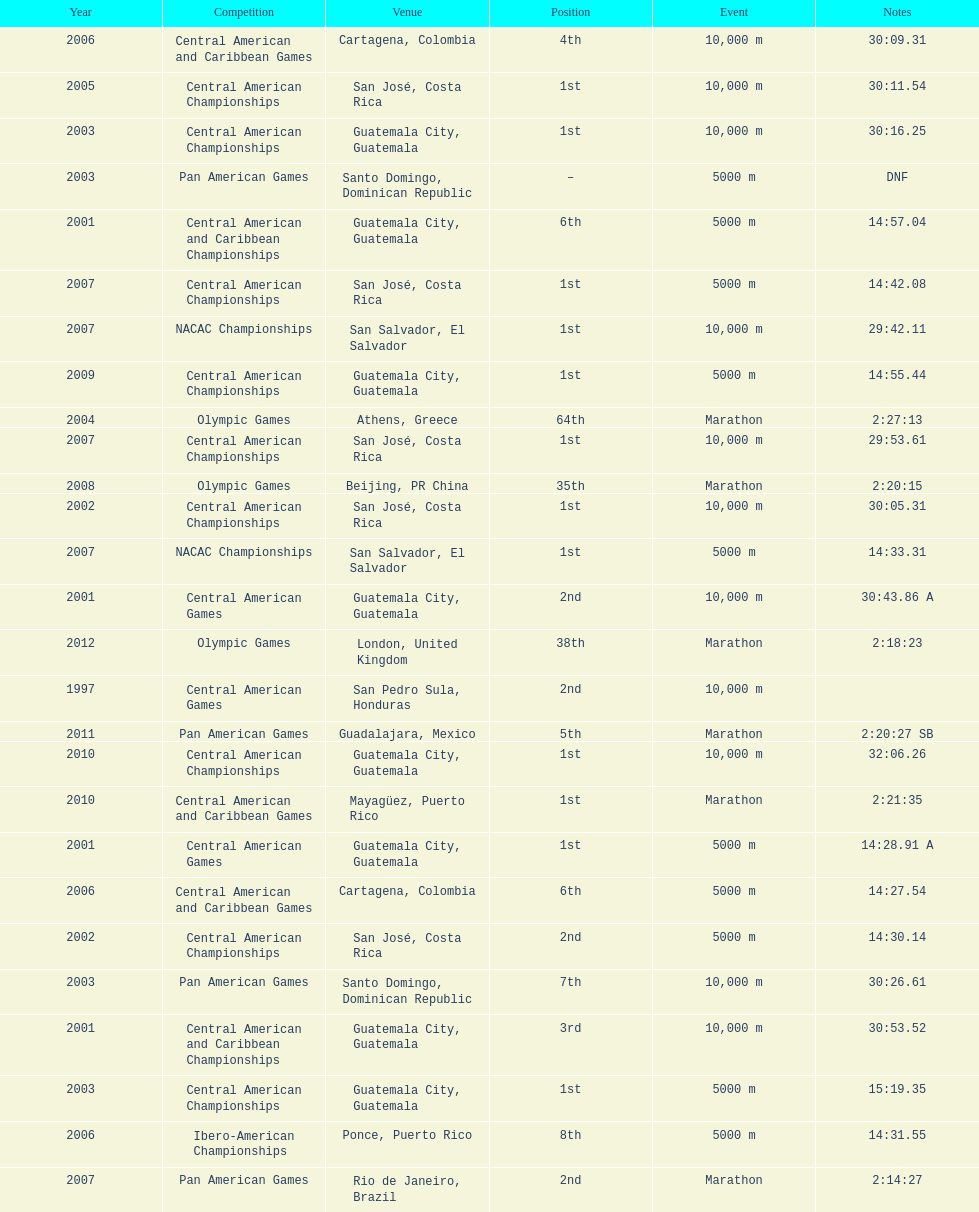How many times has the top position been accomplished? 12. 